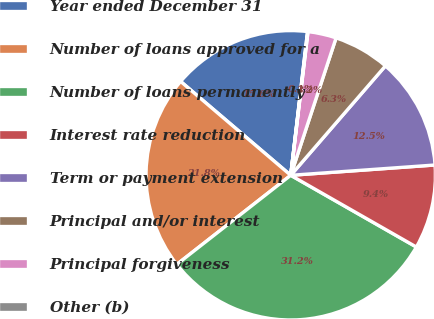Convert chart. <chart><loc_0><loc_0><loc_500><loc_500><pie_chart><fcel>Year ended December 31<fcel>Number of loans approved for a<fcel>Number of loans permanently<fcel>Interest rate reduction<fcel>Term or payment extension<fcel>Principal and/or interest<fcel>Principal forgiveness<fcel>Other (b)<nl><fcel>15.62%<fcel>21.8%<fcel>31.18%<fcel>9.39%<fcel>12.51%<fcel>6.28%<fcel>3.17%<fcel>0.05%<nl></chart> 